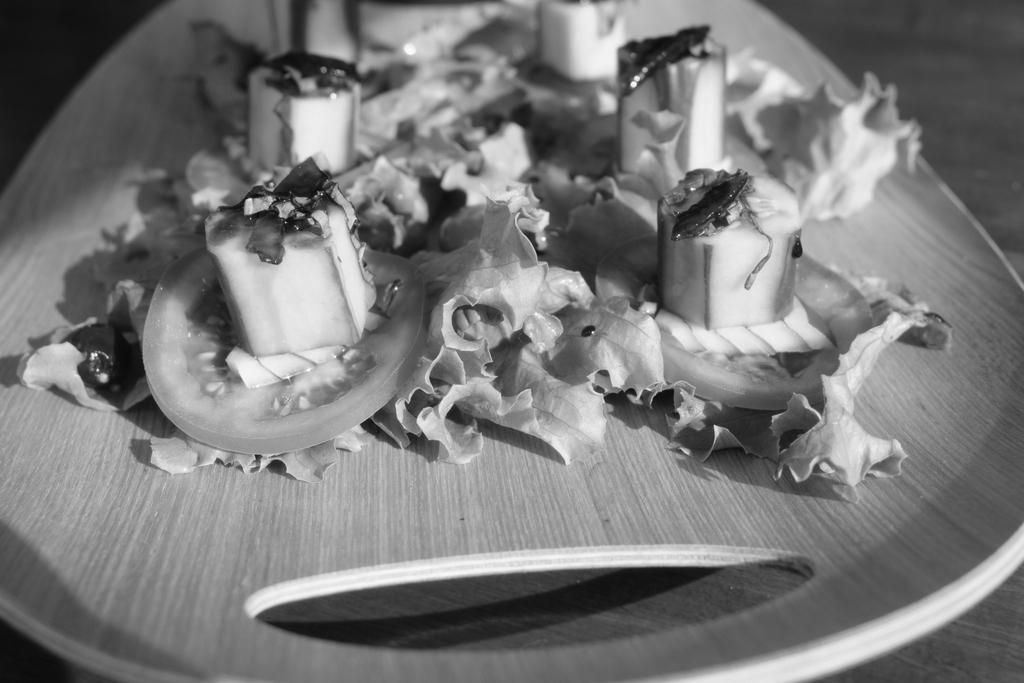What is on the plate that is visible in the image? There is food on a plate in the image. Where is the plate located in the image? The plate is in the center of the image. What type of pet can be seen interacting with the food on the plate in the image? There is no pet present in the image, and therefore no such interaction can be observed. What is the answer to the question "What is the capital of France?" in the image? The image does not contain any information related to the capital of France, so it cannot provide an answer to that question. 